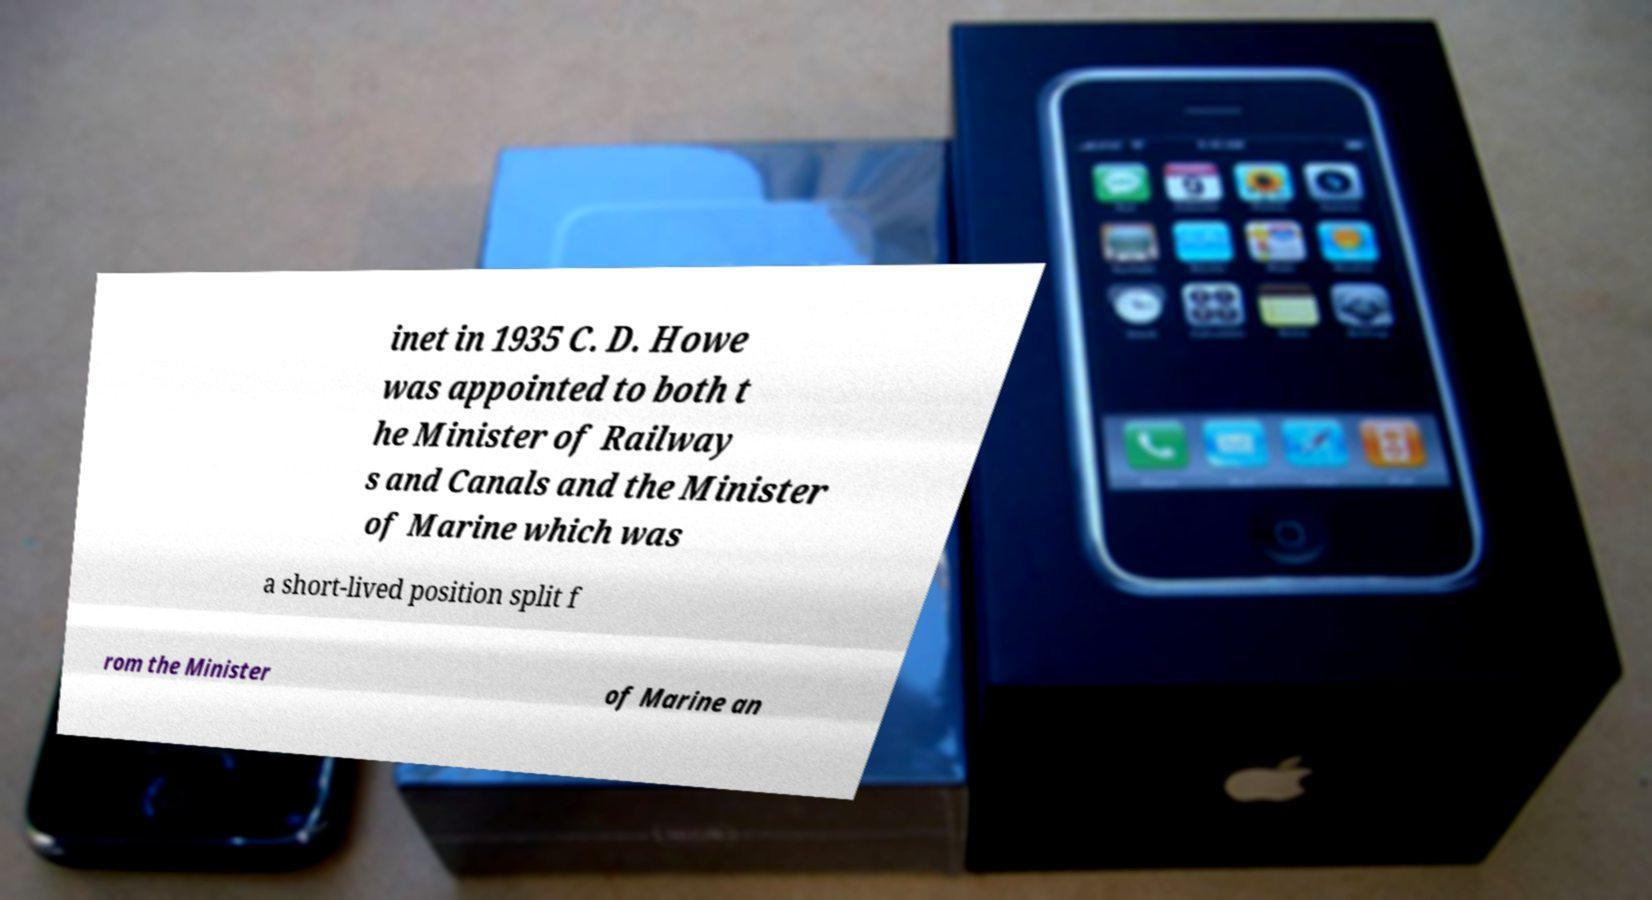Please identify and transcribe the text found in this image. inet in 1935 C. D. Howe was appointed to both t he Minister of Railway s and Canals and the Minister of Marine which was a short-lived position split f rom the Minister of Marine an 